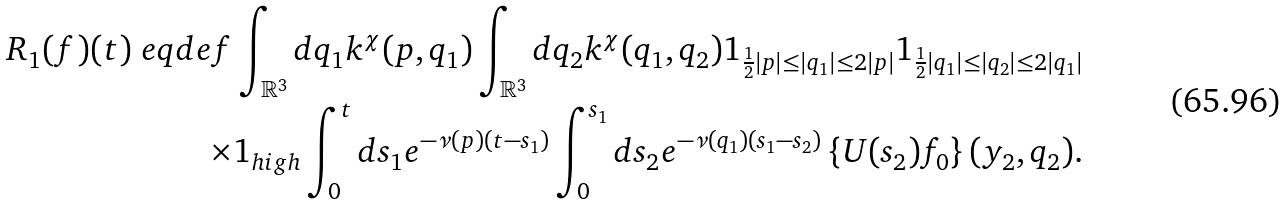Convert formula to latex. <formula><loc_0><loc_0><loc_500><loc_500>R _ { 1 } ( f ) ( t ) \ e q d e f \int _ { \mathbb { R } ^ { 3 } } d q _ { 1 } k ^ { \chi } ( p , q _ { 1 } ) \int _ { \mathbb { R } ^ { 3 } } d q _ { 2 } k ^ { \chi } ( q _ { 1 } , q _ { 2 } ) { 1 } _ { \frac { 1 } { 2 } | p | \leq | q _ { 1 } | \leq 2 | p | } { 1 } _ { \frac { 1 } { 2 } | q _ { 1 } | \leq | q _ { 2 } | \leq 2 | q _ { 1 } | } \\ \times { 1 } _ { h i g h } \int _ { 0 } ^ { t } d s _ { 1 } e ^ { - \nu ( p ) ( t - s _ { 1 } ) } \int _ { 0 } ^ { s _ { 1 } } d s _ { 2 } e ^ { - \nu ( q _ { 1 } ) ( s _ { 1 } - s _ { 2 } ) } \left \{ U ( s _ { 2 } ) f _ { 0 } \right \} ( y _ { 2 } , q _ { 2 } ) .</formula> 